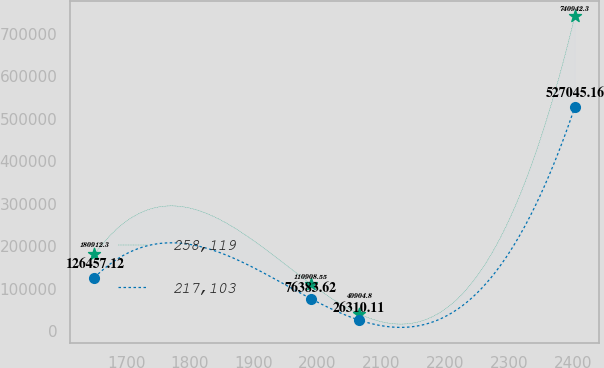Convert chart to OTSL. <chart><loc_0><loc_0><loc_500><loc_500><line_chart><ecel><fcel>258,119<fcel>217,103<nl><fcel>1650.54<fcel>180912<fcel>126457<nl><fcel>1989.86<fcel>110909<fcel>76383.6<nl><fcel>2065.11<fcel>40904.8<fcel>26310.1<nl><fcel>2403.01<fcel>740942<fcel>527045<nl></chart> 